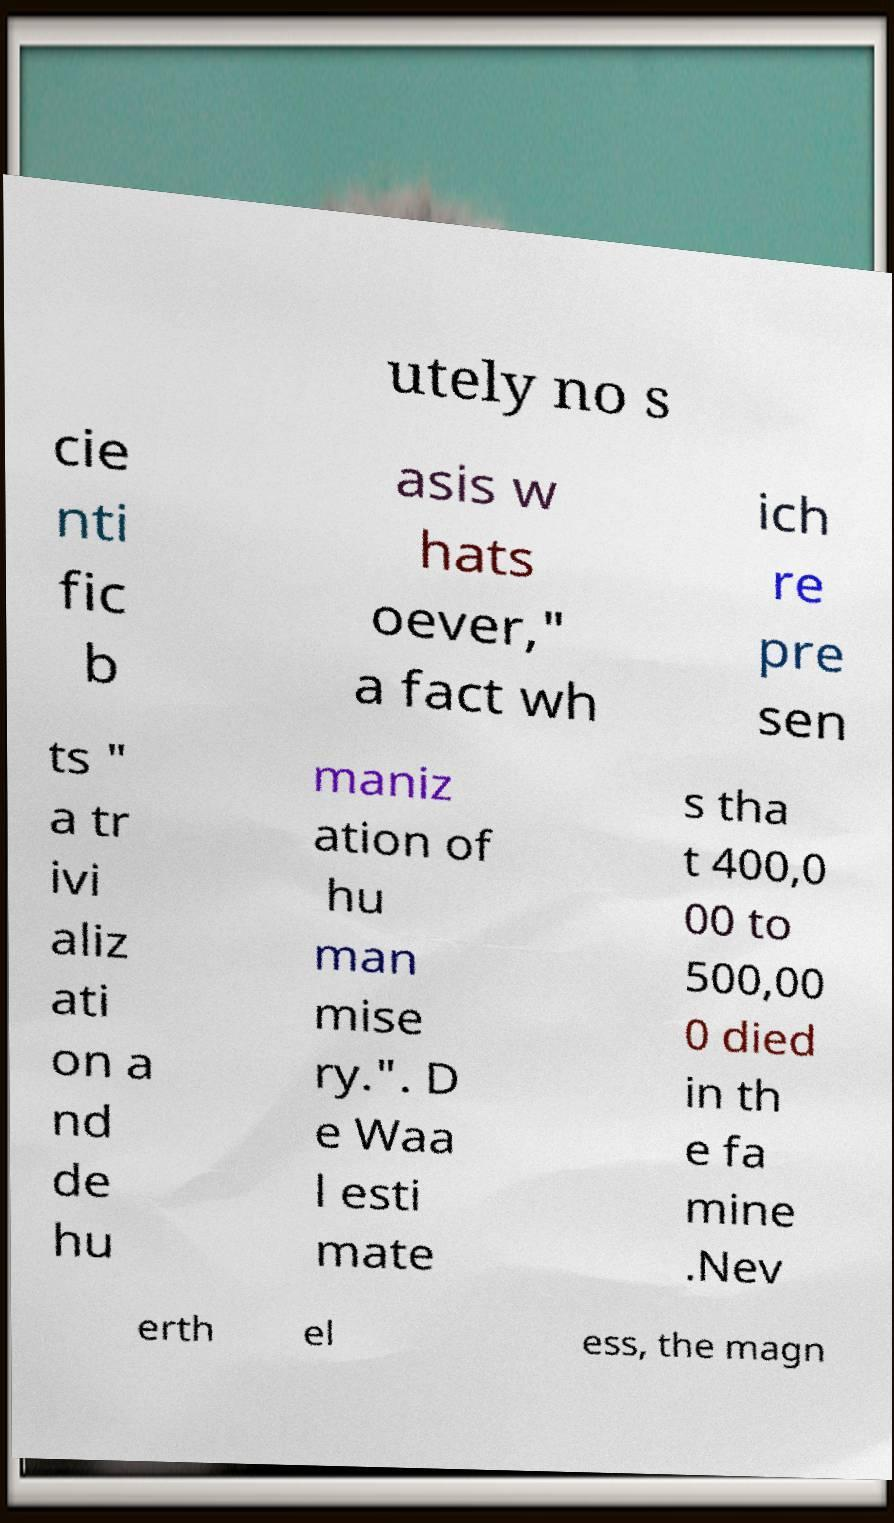Can you read and provide the text displayed in the image?This photo seems to have some interesting text. Can you extract and type it out for me? utely no s cie nti fic b asis w hats oever," a fact wh ich re pre sen ts " a tr ivi aliz ati on a nd de hu maniz ation of hu man mise ry.". D e Waa l esti mate s tha t 400,0 00 to 500,00 0 died in th e fa mine .Nev erth el ess, the magn 